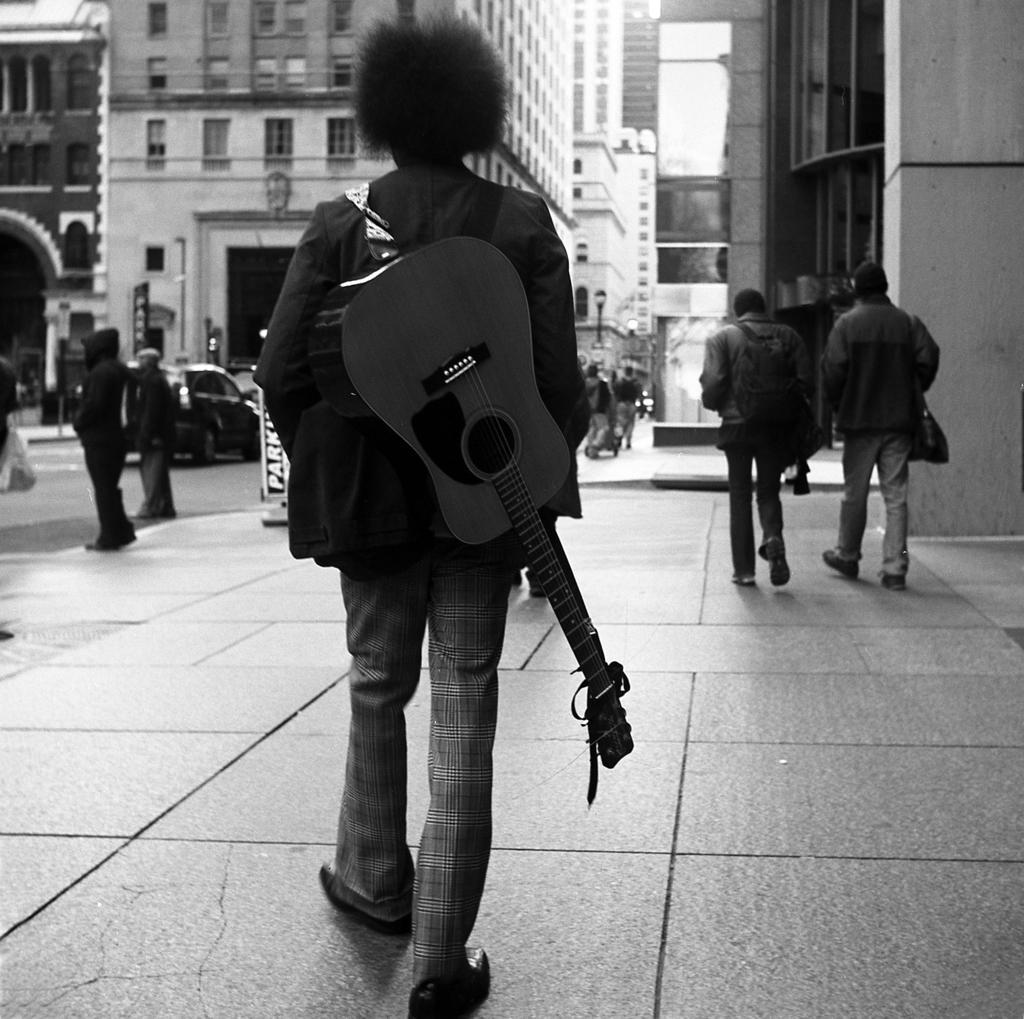Can you describe this image briefly? This picture describe about the a man who is wearing a black coat, pant and shoe holding a guitar on his back and walking through the pedestrian area. Beside him two more persons are walking holding the bag and in front we can see the buildings and car parked under the tree. 